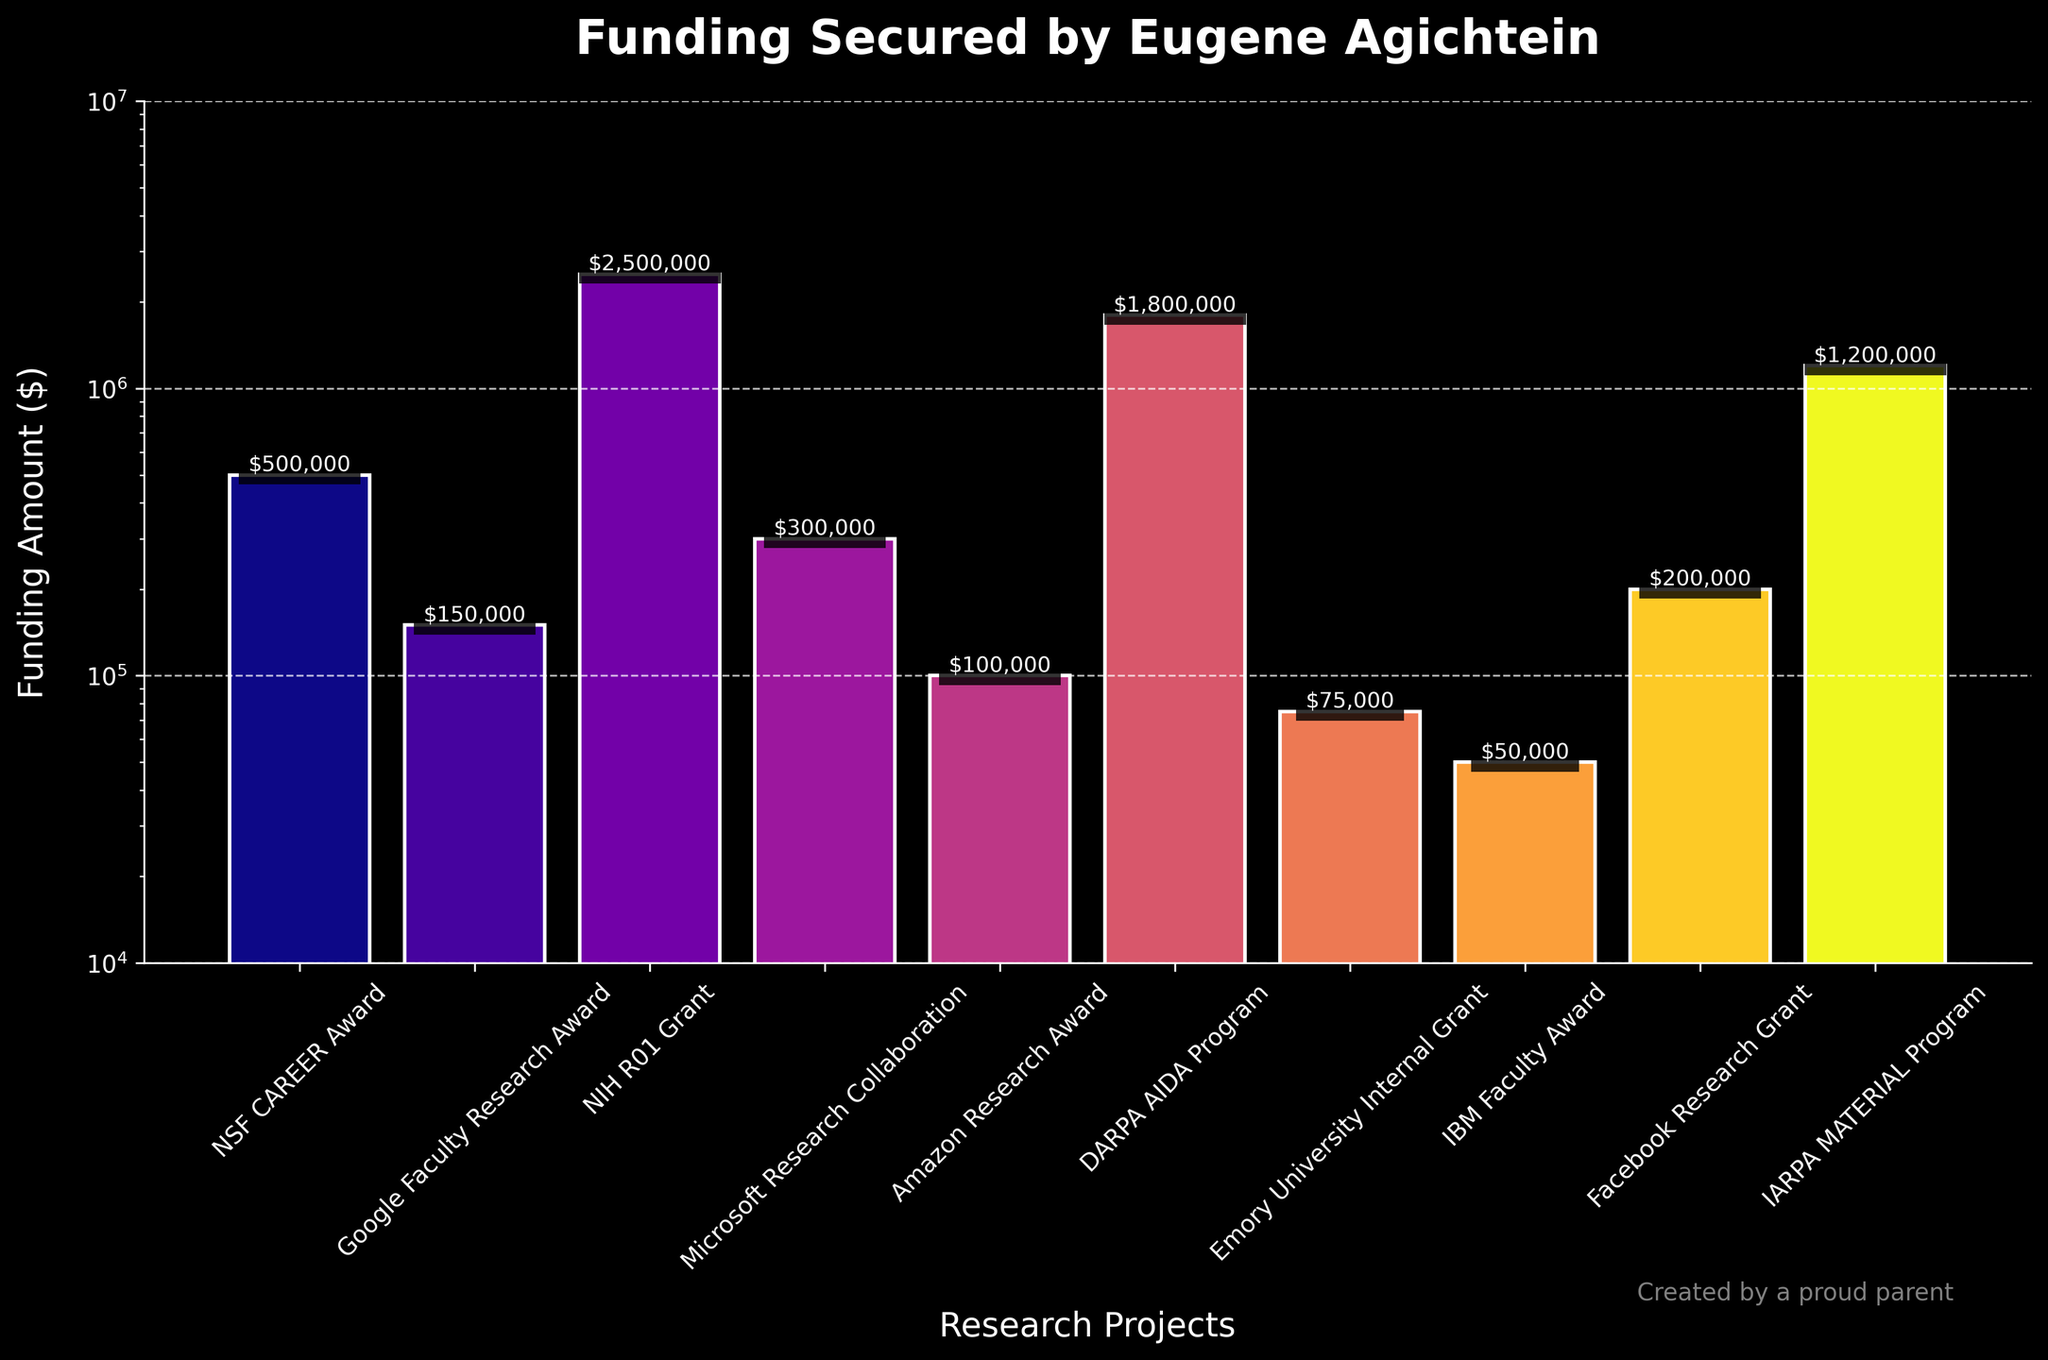Which project secured the highest funding? The project with the highest bar represents the one with the highest funding. The NIH R01 Grant has the tallest bar, indicating it is the highest funded project.
Answer: NIH R01 Grant Which project secured the lowest funding? The project with the shortest bar represents the one with the lowest funding. The IBM Faculty Award has the shortest bar, indicating it is the least funded project.
Answer: IBM Faculty Award How much more funding did the NIH R01 Grant secure compared to the NSF CAREER Award? To find the difference, subtract the NSF CAREER Award funding from the NIH R01 Grant funding. NIH R01 Grant ($2,500,000) - NSF CAREER Award ($500,000) = $2,000,000
Answer: $2,000,000 Which projects received funding amounts greater than $1,000,000? Identify the bars that are above the $1,000,000 mark. The NIH R01 Grant, DARPA AIDA Program, and IARPA MATERIAL Program all received funding greater than $1,000,000.
Answer: NIH R01 Grant, DARPA AIDA Program, IARPA MATERIAL Program How does the funding amount for the DARPA AIDA Program compare to the IARPA MATERIAL Program? Compare the heights of the bars for the two programs. The DARPA AIDA Program has a taller bar than the IARPA MATERIAL Program, meaning it secured more funding.
Answer: DARPA AIDA Program has more funding What is the total funding amount secured from Google, Amazon, and Facebook research grants combined? Add up the funding amounts from the Google Faculty Research Award ($150,000), Amazon Research Award ($100,000), and Facebook Research Grant ($200,000). $150,000 + $100,000 + $200,000 = $450,000
Answer: $450,000 Which project had funding just above the $100,000 mark? Identify the bar that is slightly above the $100,000 mark. The Google Faculty Research Award received funding of $150,000, which is just above $100,000.
Answer: Google Faculty Research Award Are there more projects with funding amounts below $500,000 or above $500,000? Count the number of bars below and above the $500,000 mark. Below $500,000: Google Faculty Research Award, Microsoft Research Collaboration, Amazon Research Award, IBM Faculty Award, Emory University Internal Grant. Above $500,000: NSF CAREER Award, NIH R01 Grant, DARPA AIDA Program, Facebook Research Grant, IARPA MATERIAL Program. There are 5 projects in each category.
Answer: Equal number 